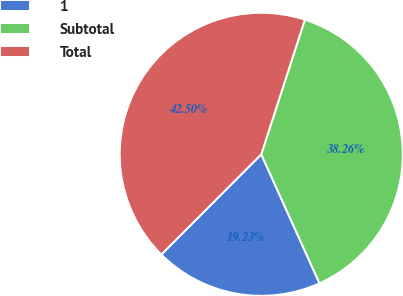<chart> <loc_0><loc_0><loc_500><loc_500><pie_chart><fcel>1<fcel>Subtotal<fcel>Total<nl><fcel>19.23%<fcel>38.26%<fcel>42.5%<nl></chart> 